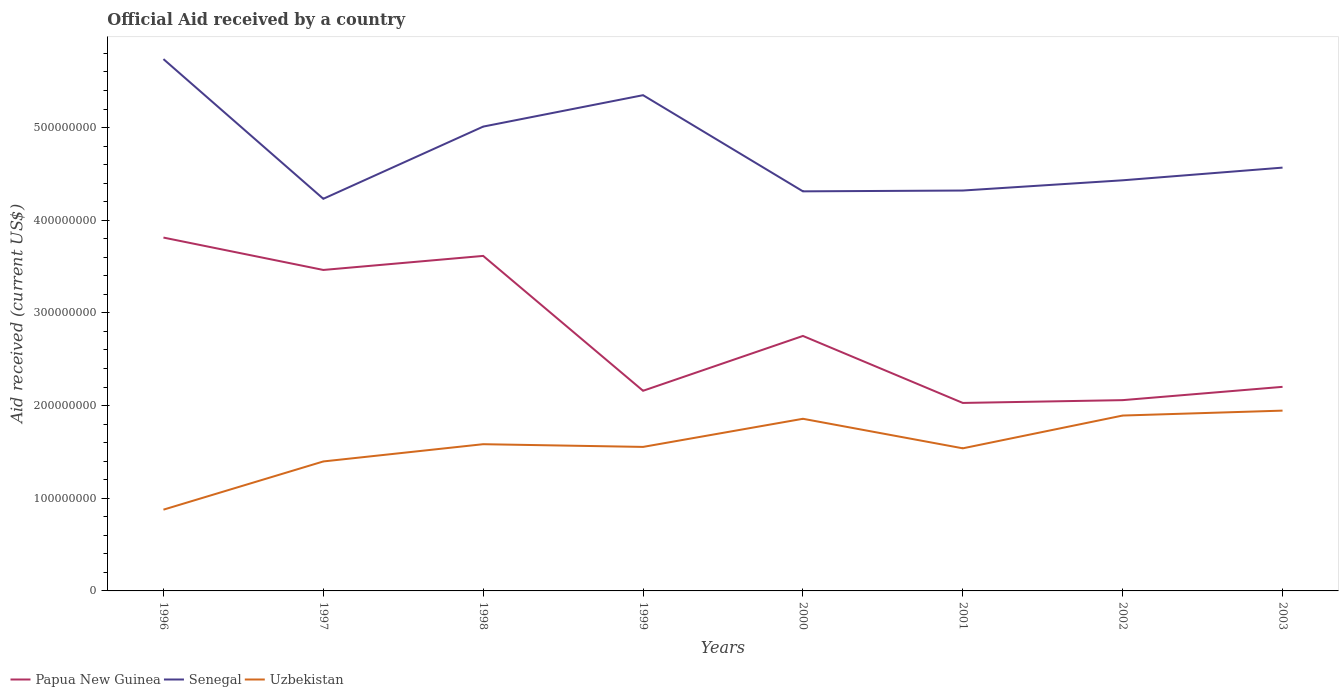Across all years, what is the maximum net official aid received in Papua New Guinea?
Your response must be concise. 2.03e+08. In which year was the net official aid received in Papua New Guinea maximum?
Your answer should be compact. 2001. What is the total net official aid received in Uzbekistan in the graph?
Your answer should be very brief. -3.09e+07. What is the difference between the highest and the second highest net official aid received in Papua New Guinea?
Provide a short and direct response. 1.78e+08. Is the net official aid received in Uzbekistan strictly greater than the net official aid received in Senegal over the years?
Offer a very short reply. Yes. Where does the legend appear in the graph?
Provide a succinct answer. Bottom left. What is the title of the graph?
Your answer should be very brief. Official Aid received by a country. Does "Bolivia" appear as one of the legend labels in the graph?
Provide a short and direct response. No. What is the label or title of the Y-axis?
Your answer should be compact. Aid received (current US$). What is the Aid received (current US$) of Papua New Guinea in 1996?
Your answer should be compact. 3.81e+08. What is the Aid received (current US$) in Senegal in 1996?
Ensure brevity in your answer.  5.74e+08. What is the Aid received (current US$) of Uzbekistan in 1996?
Make the answer very short. 8.77e+07. What is the Aid received (current US$) of Papua New Guinea in 1997?
Keep it short and to the point. 3.46e+08. What is the Aid received (current US$) in Senegal in 1997?
Keep it short and to the point. 4.23e+08. What is the Aid received (current US$) in Uzbekistan in 1997?
Ensure brevity in your answer.  1.40e+08. What is the Aid received (current US$) in Papua New Guinea in 1998?
Make the answer very short. 3.62e+08. What is the Aid received (current US$) in Senegal in 1998?
Your answer should be compact. 5.01e+08. What is the Aid received (current US$) in Uzbekistan in 1998?
Your answer should be compact. 1.58e+08. What is the Aid received (current US$) of Papua New Guinea in 1999?
Provide a short and direct response. 2.16e+08. What is the Aid received (current US$) of Senegal in 1999?
Your answer should be compact. 5.35e+08. What is the Aid received (current US$) of Uzbekistan in 1999?
Give a very brief answer. 1.55e+08. What is the Aid received (current US$) of Papua New Guinea in 2000?
Provide a short and direct response. 2.75e+08. What is the Aid received (current US$) in Senegal in 2000?
Provide a succinct answer. 4.31e+08. What is the Aid received (current US$) of Uzbekistan in 2000?
Provide a succinct answer. 1.86e+08. What is the Aid received (current US$) in Papua New Guinea in 2001?
Give a very brief answer. 2.03e+08. What is the Aid received (current US$) in Senegal in 2001?
Make the answer very short. 4.32e+08. What is the Aid received (current US$) of Uzbekistan in 2001?
Provide a short and direct response. 1.54e+08. What is the Aid received (current US$) in Papua New Guinea in 2002?
Offer a terse response. 2.06e+08. What is the Aid received (current US$) in Senegal in 2002?
Ensure brevity in your answer.  4.43e+08. What is the Aid received (current US$) in Uzbekistan in 2002?
Make the answer very short. 1.89e+08. What is the Aid received (current US$) of Papua New Guinea in 2003?
Give a very brief answer. 2.20e+08. What is the Aid received (current US$) of Senegal in 2003?
Offer a very short reply. 4.57e+08. What is the Aid received (current US$) of Uzbekistan in 2003?
Offer a very short reply. 1.95e+08. Across all years, what is the maximum Aid received (current US$) of Papua New Guinea?
Offer a terse response. 3.81e+08. Across all years, what is the maximum Aid received (current US$) of Senegal?
Your answer should be very brief. 5.74e+08. Across all years, what is the maximum Aid received (current US$) in Uzbekistan?
Offer a very short reply. 1.95e+08. Across all years, what is the minimum Aid received (current US$) in Papua New Guinea?
Make the answer very short. 2.03e+08. Across all years, what is the minimum Aid received (current US$) of Senegal?
Provide a succinct answer. 4.23e+08. Across all years, what is the minimum Aid received (current US$) in Uzbekistan?
Your answer should be very brief. 8.77e+07. What is the total Aid received (current US$) in Papua New Guinea in the graph?
Provide a short and direct response. 2.21e+09. What is the total Aid received (current US$) of Senegal in the graph?
Keep it short and to the point. 3.80e+09. What is the total Aid received (current US$) of Uzbekistan in the graph?
Provide a succinct answer. 1.26e+09. What is the difference between the Aid received (current US$) in Papua New Guinea in 1996 and that in 1997?
Offer a terse response. 3.50e+07. What is the difference between the Aid received (current US$) of Senegal in 1996 and that in 1997?
Provide a short and direct response. 1.51e+08. What is the difference between the Aid received (current US$) in Uzbekistan in 1996 and that in 1997?
Your answer should be very brief. -5.20e+07. What is the difference between the Aid received (current US$) of Papua New Guinea in 1996 and that in 1998?
Provide a succinct answer. 1.98e+07. What is the difference between the Aid received (current US$) in Senegal in 1996 and that in 1998?
Give a very brief answer. 7.28e+07. What is the difference between the Aid received (current US$) of Uzbekistan in 1996 and that in 1998?
Offer a very short reply. -7.06e+07. What is the difference between the Aid received (current US$) in Papua New Guinea in 1996 and that in 1999?
Your answer should be compact. 1.65e+08. What is the difference between the Aid received (current US$) of Senegal in 1996 and that in 1999?
Keep it short and to the point. 3.89e+07. What is the difference between the Aid received (current US$) in Uzbekistan in 1996 and that in 1999?
Your response must be concise. -6.77e+07. What is the difference between the Aid received (current US$) of Papua New Guinea in 1996 and that in 2000?
Your response must be concise. 1.06e+08. What is the difference between the Aid received (current US$) in Senegal in 1996 and that in 2000?
Give a very brief answer. 1.43e+08. What is the difference between the Aid received (current US$) of Uzbekistan in 1996 and that in 2000?
Make the answer very short. -9.81e+07. What is the difference between the Aid received (current US$) of Papua New Guinea in 1996 and that in 2001?
Offer a very short reply. 1.78e+08. What is the difference between the Aid received (current US$) of Senegal in 1996 and that in 2001?
Keep it short and to the point. 1.42e+08. What is the difference between the Aid received (current US$) of Uzbekistan in 1996 and that in 2001?
Ensure brevity in your answer.  -6.62e+07. What is the difference between the Aid received (current US$) of Papua New Guinea in 1996 and that in 2002?
Your answer should be very brief. 1.75e+08. What is the difference between the Aid received (current US$) of Senegal in 1996 and that in 2002?
Provide a succinct answer. 1.31e+08. What is the difference between the Aid received (current US$) in Uzbekistan in 1996 and that in 2002?
Ensure brevity in your answer.  -1.02e+08. What is the difference between the Aid received (current US$) of Papua New Guinea in 1996 and that in 2003?
Provide a short and direct response. 1.61e+08. What is the difference between the Aid received (current US$) in Senegal in 1996 and that in 2003?
Offer a terse response. 1.17e+08. What is the difference between the Aid received (current US$) in Uzbekistan in 1996 and that in 2003?
Make the answer very short. -1.07e+08. What is the difference between the Aid received (current US$) in Papua New Guinea in 1997 and that in 1998?
Provide a succinct answer. -1.52e+07. What is the difference between the Aid received (current US$) in Senegal in 1997 and that in 1998?
Your response must be concise. -7.79e+07. What is the difference between the Aid received (current US$) in Uzbekistan in 1997 and that in 1998?
Your answer should be compact. -1.86e+07. What is the difference between the Aid received (current US$) in Papua New Guinea in 1997 and that in 1999?
Your response must be concise. 1.30e+08. What is the difference between the Aid received (current US$) of Senegal in 1997 and that in 1999?
Your answer should be compact. -1.12e+08. What is the difference between the Aid received (current US$) of Uzbekistan in 1997 and that in 1999?
Provide a succinct answer. -1.57e+07. What is the difference between the Aid received (current US$) of Papua New Guinea in 1997 and that in 2000?
Offer a very short reply. 7.12e+07. What is the difference between the Aid received (current US$) of Senegal in 1997 and that in 2000?
Offer a terse response. -8.04e+06. What is the difference between the Aid received (current US$) in Uzbekistan in 1997 and that in 2000?
Your response must be concise. -4.60e+07. What is the difference between the Aid received (current US$) in Papua New Guinea in 1997 and that in 2001?
Make the answer very short. 1.44e+08. What is the difference between the Aid received (current US$) in Senegal in 1997 and that in 2001?
Your answer should be compact. -8.92e+06. What is the difference between the Aid received (current US$) of Uzbekistan in 1997 and that in 2001?
Make the answer very short. -1.42e+07. What is the difference between the Aid received (current US$) of Papua New Guinea in 1997 and that in 2002?
Ensure brevity in your answer.  1.40e+08. What is the difference between the Aid received (current US$) of Senegal in 1997 and that in 2002?
Offer a terse response. -2.00e+07. What is the difference between the Aid received (current US$) in Uzbekistan in 1997 and that in 2002?
Offer a very short reply. -4.95e+07. What is the difference between the Aid received (current US$) in Papua New Guinea in 1997 and that in 2003?
Offer a very short reply. 1.26e+08. What is the difference between the Aid received (current US$) of Senegal in 1997 and that in 2003?
Provide a short and direct response. -3.36e+07. What is the difference between the Aid received (current US$) of Uzbekistan in 1997 and that in 2003?
Give a very brief answer. -5.48e+07. What is the difference between the Aid received (current US$) of Papua New Guinea in 1998 and that in 1999?
Your answer should be compact. 1.46e+08. What is the difference between the Aid received (current US$) of Senegal in 1998 and that in 1999?
Give a very brief answer. -3.39e+07. What is the difference between the Aid received (current US$) in Uzbekistan in 1998 and that in 1999?
Offer a very short reply. 2.93e+06. What is the difference between the Aid received (current US$) in Papua New Guinea in 1998 and that in 2000?
Offer a terse response. 8.64e+07. What is the difference between the Aid received (current US$) of Senegal in 1998 and that in 2000?
Your answer should be very brief. 6.99e+07. What is the difference between the Aid received (current US$) in Uzbekistan in 1998 and that in 2000?
Keep it short and to the point. -2.74e+07. What is the difference between the Aid received (current US$) in Papua New Guinea in 1998 and that in 2001?
Provide a short and direct response. 1.59e+08. What is the difference between the Aid received (current US$) of Senegal in 1998 and that in 2001?
Keep it short and to the point. 6.90e+07. What is the difference between the Aid received (current US$) of Uzbekistan in 1998 and that in 2001?
Provide a short and direct response. 4.45e+06. What is the difference between the Aid received (current US$) of Papua New Guinea in 1998 and that in 2002?
Provide a succinct answer. 1.56e+08. What is the difference between the Aid received (current US$) in Senegal in 1998 and that in 2002?
Your answer should be compact. 5.80e+07. What is the difference between the Aid received (current US$) of Uzbekistan in 1998 and that in 2002?
Your answer should be very brief. -3.09e+07. What is the difference between the Aid received (current US$) of Papua New Guinea in 1998 and that in 2003?
Offer a terse response. 1.41e+08. What is the difference between the Aid received (current US$) of Senegal in 1998 and that in 2003?
Your answer should be compact. 4.43e+07. What is the difference between the Aid received (current US$) in Uzbekistan in 1998 and that in 2003?
Provide a short and direct response. -3.62e+07. What is the difference between the Aid received (current US$) in Papua New Guinea in 1999 and that in 2000?
Your answer should be compact. -5.92e+07. What is the difference between the Aid received (current US$) of Senegal in 1999 and that in 2000?
Provide a short and direct response. 1.04e+08. What is the difference between the Aid received (current US$) in Uzbekistan in 1999 and that in 2000?
Offer a very short reply. -3.04e+07. What is the difference between the Aid received (current US$) of Papua New Guinea in 1999 and that in 2001?
Your answer should be very brief. 1.31e+07. What is the difference between the Aid received (current US$) in Senegal in 1999 and that in 2001?
Your answer should be very brief. 1.03e+08. What is the difference between the Aid received (current US$) in Uzbekistan in 1999 and that in 2001?
Make the answer very short. 1.52e+06. What is the difference between the Aid received (current US$) of Papua New Guinea in 1999 and that in 2002?
Your response must be concise. 1.01e+07. What is the difference between the Aid received (current US$) of Senegal in 1999 and that in 2002?
Provide a short and direct response. 9.18e+07. What is the difference between the Aid received (current US$) of Uzbekistan in 1999 and that in 2002?
Offer a terse response. -3.38e+07. What is the difference between the Aid received (current US$) of Papua New Guinea in 1999 and that in 2003?
Your answer should be compact. -4.25e+06. What is the difference between the Aid received (current US$) in Senegal in 1999 and that in 2003?
Provide a short and direct response. 7.82e+07. What is the difference between the Aid received (current US$) of Uzbekistan in 1999 and that in 2003?
Make the answer very short. -3.92e+07. What is the difference between the Aid received (current US$) of Papua New Guinea in 2000 and that in 2001?
Offer a very short reply. 7.23e+07. What is the difference between the Aid received (current US$) in Senegal in 2000 and that in 2001?
Provide a succinct answer. -8.80e+05. What is the difference between the Aid received (current US$) of Uzbekistan in 2000 and that in 2001?
Ensure brevity in your answer.  3.19e+07. What is the difference between the Aid received (current US$) in Papua New Guinea in 2000 and that in 2002?
Your answer should be compact. 6.93e+07. What is the difference between the Aid received (current US$) of Senegal in 2000 and that in 2002?
Keep it short and to the point. -1.19e+07. What is the difference between the Aid received (current US$) of Uzbekistan in 2000 and that in 2002?
Provide a succinct answer. -3.50e+06. What is the difference between the Aid received (current US$) of Papua New Guinea in 2000 and that in 2003?
Make the answer very short. 5.49e+07. What is the difference between the Aid received (current US$) in Senegal in 2000 and that in 2003?
Your response must be concise. -2.56e+07. What is the difference between the Aid received (current US$) of Uzbekistan in 2000 and that in 2003?
Give a very brief answer. -8.80e+06. What is the difference between the Aid received (current US$) of Papua New Guinea in 2001 and that in 2002?
Your answer should be compact. -3.02e+06. What is the difference between the Aid received (current US$) in Senegal in 2001 and that in 2002?
Give a very brief answer. -1.10e+07. What is the difference between the Aid received (current US$) in Uzbekistan in 2001 and that in 2002?
Offer a very short reply. -3.54e+07. What is the difference between the Aid received (current US$) of Papua New Guinea in 2001 and that in 2003?
Your answer should be very brief. -1.74e+07. What is the difference between the Aid received (current US$) in Senegal in 2001 and that in 2003?
Give a very brief answer. -2.47e+07. What is the difference between the Aid received (current US$) of Uzbekistan in 2001 and that in 2003?
Provide a short and direct response. -4.07e+07. What is the difference between the Aid received (current US$) in Papua New Guinea in 2002 and that in 2003?
Your answer should be very brief. -1.44e+07. What is the difference between the Aid received (current US$) of Senegal in 2002 and that in 2003?
Your response must be concise. -1.37e+07. What is the difference between the Aid received (current US$) of Uzbekistan in 2002 and that in 2003?
Your answer should be very brief. -5.30e+06. What is the difference between the Aid received (current US$) in Papua New Guinea in 1996 and the Aid received (current US$) in Senegal in 1997?
Your response must be concise. -4.18e+07. What is the difference between the Aid received (current US$) in Papua New Guinea in 1996 and the Aid received (current US$) in Uzbekistan in 1997?
Provide a succinct answer. 2.42e+08. What is the difference between the Aid received (current US$) of Senegal in 1996 and the Aid received (current US$) of Uzbekistan in 1997?
Offer a terse response. 4.34e+08. What is the difference between the Aid received (current US$) in Papua New Guinea in 1996 and the Aid received (current US$) in Senegal in 1998?
Keep it short and to the point. -1.20e+08. What is the difference between the Aid received (current US$) of Papua New Guinea in 1996 and the Aid received (current US$) of Uzbekistan in 1998?
Your answer should be compact. 2.23e+08. What is the difference between the Aid received (current US$) of Senegal in 1996 and the Aid received (current US$) of Uzbekistan in 1998?
Give a very brief answer. 4.16e+08. What is the difference between the Aid received (current US$) in Papua New Guinea in 1996 and the Aid received (current US$) in Senegal in 1999?
Provide a succinct answer. -1.54e+08. What is the difference between the Aid received (current US$) in Papua New Guinea in 1996 and the Aid received (current US$) in Uzbekistan in 1999?
Give a very brief answer. 2.26e+08. What is the difference between the Aid received (current US$) of Senegal in 1996 and the Aid received (current US$) of Uzbekistan in 1999?
Your answer should be compact. 4.18e+08. What is the difference between the Aid received (current US$) in Papua New Guinea in 1996 and the Aid received (current US$) in Senegal in 2000?
Provide a short and direct response. -4.99e+07. What is the difference between the Aid received (current US$) in Papua New Guinea in 1996 and the Aid received (current US$) in Uzbekistan in 2000?
Make the answer very short. 1.96e+08. What is the difference between the Aid received (current US$) in Senegal in 1996 and the Aid received (current US$) in Uzbekistan in 2000?
Ensure brevity in your answer.  3.88e+08. What is the difference between the Aid received (current US$) in Papua New Guinea in 1996 and the Aid received (current US$) in Senegal in 2001?
Offer a very short reply. -5.08e+07. What is the difference between the Aid received (current US$) of Papua New Guinea in 1996 and the Aid received (current US$) of Uzbekistan in 2001?
Provide a short and direct response. 2.27e+08. What is the difference between the Aid received (current US$) of Senegal in 1996 and the Aid received (current US$) of Uzbekistan in 2001?
Ensure brevity in your answer.  4.20e+08. What is the difference between the Aid received (current US$) of Papua New Guinea in 1996 and the Aid received (current US$) of Senegal in 2002?
Your answer should be compact. -6.18e+07. What is the difference between the Aid received (current US$) in Papua New Guinea in 1996 and the Aid received (current US$) in Uzbekistan in 2002?
Offer a very short reply. 1.92e+08. What is the difference between the Aid received (current US$) of Senegal in 1996 and the Aid received (current US$) of Uzbekistan in 2002?
Give a very brief answer. 3.85e+08. What is the difference between the Aid received (current US$) in Papua New Guinea in 1996 and the Aid received (current US$) in Senegal in 2003?
Give a very brief answer. -7.55e+07. What is the difference between the Aid received (current US$) of Papua New Guinea in 1996 and the Aid received (current US$) of Uzbekistan in 2003?
Give a very brief answer. 1.87e+08. What is the difference between the Aid received (current US$) of Senegal in 1996 and the Aid received (current US$) of Uzbekistan in 2003?
Your answer should be very brief. 3.79e+08. What is the difference between the Aid received (current US$) in Papua New Guinea in 1997 and the Aid received (current US$) in Senegal in 1998?
Your answer should be compact. -1.55e+08. What is the difference between the Aid received (current US$) in Papua New Guinea in 1997 and the Aid received (current US$) in Uzbekistan in 1998?
Make the answer very short. 1.88e+08. What is the difference between the Aid received (current US$) in Senegal in 1997 and the Aid received (current US$) in Uzbekistan in 1998?
Keep it short and to the point. 2.65e+08. What is the difference between the Aid received (current US$) in Papua New Guinea in 1997 and the Aid received (current US$) in Senegal in 1999?
Provide a short and direct response. -1.89e+08. What is the difference between the Aid received (current US$) in Papua New Guinea in 1997 and the Aid received (current US$) in Uzbekistan in 1999?
Keep it short and to the point. 1.91e+08. What is the difference between the Aid received (current US$) of Senegal in 1997 and the Aid received (current US$) of Uzbekistan in 1999?
Make the answer very short. 2.68e+08. What is the difference between the Aid received (current US$) in Papua New Guinea in 1997 and the Aid received (current US$) in Senegal in 2000?
Make the answer very short. -8.48e+07. What is the difference between the Aid received (current US$) in Papua New Guinea in 1997 and the Aid received (current US$) in Uzbekistan in 2000?
Offer a terse response. 1.61e+08. What is the difference between the Aid received (current US$) of Senegal in 1997 and the Aid received (current US$) of Uzbekistan in 2000?
Your answer should be compact. 2.37e+08. What is the difference between the Aid received (current US$) of Papua New Guinea in 1997 and the Aid received (current US$) of Senegal in 2001?
Offer a terse response. -8.57e+07. What is the difference between the Aid received (current US$) in Papua New Guinea in 1997 and the Aid received (current US$) in Uzbekistan in 2001?
Give a very brief answer. 1.92e+08. What is the difference between the Aid received (current US$) in Senegal in 1997 and the Aid received (current US$) in Uzbekistan in 2001?
Keep it short and to the point. 2.69e+08. What is the difference between the Aid received (current US$) in Papua New Guinea in 1997 and the Aid received (current US$) in Senegal in 2002?
Make the answer very short. -9.68e+07. What is the difference between the Aid received (current US$) in Papua New Guinea in 1997 and the Aid received (current US$) in Uzbekistan in 2002?
Offer a very short reply. 1.57e+08. What is the difference between the Aid received (current US$) of Senegal in 1997 and the Aid received (current US$) of Uzbekistan in 2002?
Provide a succinct answer. 2.34e+08. What is the difference between the Aid received (current US$) in Papua New Guinea in 1997 and the Aid received (current US$) in Senegal in 2003?
Provide a short and direct response. -1.10e+08. What is the difference between the Aid received (current US$) of Papua New Guinea in 1997 and the Aid received (current US$) of Uzbekistan in 2003?
Offer a very short reply. 1.52e+08. What is the difference between the Aid received (current US$) in Senegal in 1997 and the Aid received (current US$) in Uzbekistan in 2003?
Your answer should be compact. 2.29e+08. What is the difference between the Aid received (current US$) in Papua New Guinea in 1998 and the Aid received (current US$) in Senegal in 1999?
Give a very brief answer. -1.73e+08. What is the difference between the Aid received (current US$) of Papua New Guinea in 1998 and the Aid received (current US$) of Uzbekistan in 1999?
Your answer should be very brief. 2.06e+08. What is the difference between the Aid received (current US$) in Senegal in 1998 and the Aid received (current US$) in Uzbekistan in 1999?
Keep it short and to the point. 3.46e+08. What is the difference between the Aid received (current US$) of Papua New Guinea in 1998 and the Aid received (current US$) of Senegal in 2000?
Offer a terse response. -6.97e+07. What is the difference between the Aid received (current US$) of Papua New Guinea in 1998 and the Aid received (current US$) of Uzbekistan in 2000?
Give a very brief answer. 1.76e+08. What is the difference between the Aid received (current US$) of Senegal in 1998 and the Aid received (current US$) of Uzbekistan in 2000?
Your answer should be compact. 3.15e+08. What is the difference between the Aid received (current US$) in Papua New Guinea in 1998 and the Aid received (current US$) in Senegal in 2001?
Provide a short and direct response. -7.06e+07. What is the difference between the Aid received (current US$) in Papua New Guinea in 1998 and the Aid received (current US$) in Uzbekistan in 2001?
Offer a terse response. 2.08e+08. What is the difference between the Aid received (current US$) of Senegal in 1998 and the Aid received (current US$) of Uzbekistan in 2001?
Ensure brevity in your answer.  3.47e+08. What is the difference between the Aid received (current US$) in Papua New Guinea in 1998 and the Aid received (current US$) in Senegal in 2002?
Ensure brevity in your answer.  -8.16e+07. What is the difference between the Aid received (current US$) in Papua New Guinea in 1998 and the Aid received (current US$) in Uzbekistan in 2002?
Give a very brief answer. 1.72e+08. What is the difference between the Aid received (current US$) in Senegal in 1998 and the Aid received (current US$) in Uzbekistan in 2002?
Keep it short and to the point. 3.12e+08. What is the difference between the Aid received (current US$) of Papua New Guinea in 1998 and the Aid received (current US$) of Senegal in 2003?
Offer a terse response. -9.53e+07. What is the difference between the Aid received (current US$) of Papua New Guinea in 1998 and the Aid received (current US$) of Uzbekistan in 2003?
Keep it short and to the point. 1.67e+08. What is the difference between the Aid received (current US$) of Senegal in 1998 and the Aid received (current US$) of Uzbekistan in 2003?
Offer a terse response. 3.06e+08. What is the difference between the Aid received (current US$) of Papua New Guinea in 1999 and the Aid received (current US$) of Senegal in 2000?
Keep it short and to the point. -2.15e+08. What is the difference between the Aid received (current US$) in Papua New Guinea in 1999 and the Aid received (current US$) in Uzbekistan in 2000?
Provide a succinct answer. 3.02e+07. What is the difference between the Aid received (current US$) of Senegal in 1999 and the Aid received (current US$) of Uzbekistan in 2000?
Offer a terse response. 3.49e+08. What is the difference between the Aid received (current US$) of Papua New Guinea in 1999 and the Aid received (current US$) of Senegal in 2001?
Offer a very short reply. -2.16e+08. What is the difference between the Aid received (current US$) in Papua New Guinea in 1999 and the Aid received (current US$) in Uzbekistan in 2001?
Your response must be concise. 6.21e+07. What is the difference between the Aid received (current US$) of Senegal in 1999 and the Aid received (current US$) of Uzbekistan in 2001?
Provide a succinct answer. 3.81e+08. What is the difference between the Aid received (current US$) in Papua New Guinea in 1999 and the Aid received (current US$) in Senegal in 2002?
Your answer should be compact. -2.27e+08. What is the difference between the Aid received (current US$) of Papua New Guinea in 1999 and the Aid received (current US$) of Uzbekistan in 2002?
Provide a short and direct response. 2.67e+07. What is the difference between the Aid received (current US$) in Senegal in 1999 and the Aid received (current US$) in Uzbekistan in 2002?
Provide a short and direct response. 3.46e+08. What is the difference between the Aid received (current US$) in Papua New Guinea in 1999 and the Aid received (current US$) in Senegal in 2003?
Offer a terse response. -2.41e+08. What is the difference between the Aid received (current US$) of Papua New Guinea in 1999 and the Aid received (current US$) of Uzbekistan in 2003?
Provide a succinct answer. 2.14e+07. What is the difference between the Aid received (current US$) in Senegal in 1999 and the Aid received (current US$) in Uzbekistan in 2003?
Your response must be concise. 3.40e+08. What is the difference between the Aid received (current US$) in Papua New Guinea in 2000 and the Aid received (current US$) in Senegal in 2001?
Provide a short and direct response. -1.57e+08. What is the difference between the Aid received (current US$) in Papua New Guinea in 2000 and the Aid received (current US$) in Uzbekistan in 2001?
Give a very brief answer. 1.21e+08. What is the difference between the Aid received (current US$) of Senegal in 2000 and the Aid received (current US$) of Uzbekistan in 2001?
Offer a very short reply. 2.77e+08. What is the difference between the Aid received (current US$) in Papua New Guinea in 2000 and the Aid received (current US$) in Senegal in 2002?
Offer a very short reply. -1.68e+08. What is the difference between the Aid received (current US$) of Papua New Guinea in 2000 and the Aid received (current US$) of Uzbekistan in 2002?
Your response must be concise. 8.59e+07. What is the difference between the Aid received (current US$) in Senegal in 2000 and the Aid received (current US$) in Uzbekistan in 2002?
Ensure brevity in your answer.  2.42e+08. What is the difference between the Aid received (current US$) in Papua New Guinea in 2000 and the Aid received (current US$) in Senegal in 2003?
Ensure brevity in your answer.  -1.82e+08. What is the difference between the Aid received (current US$) in Papua New Guinea in 2000 and the Aid received (current US$) in Uzbekistan in 2003?
Offer a terse response. 8.06e+07. What is the difference between the Aid received (current US$) of Senegal in 2000 and the Aid received (current US$) of Uzbekistan in 2003?
Provide a succinct answer. 2.37e+08. What is the difference between the Aid received (current US$) of Papua New Guinea in 2001 and the Aid received (current US$) of Senegal in 2002?
Offer a very short reply. -2.40e+08. What is the difference between the Aid received (current US$) in Papua New Guinea in 2001 and the Aid received (current US$) in Uzbekistan in 2002?
Provide a short and direct response. 1.36e+07. What is the difference between the Aid received (current US$) in Senegal in 2001 and the Aid received (current US$) in Uzbekistan in 2002?
Provide a short and direct response. 2.43e+08. What is the difference between the Aid received (current US$) in Papua New Guinea in 2001 and the Aid received (current US$) in Senegal in 2003?
Offer a very short reply. -2.54e+08. What is the difference between the Aid received (current US$) of Papua New Guinea in 2001 and the Aid received (current US$) of Uzbekistan in 2003?
Your answer should be very brief. 8.30e+06. What is the difference between the Aid received (current US$) of Senegal in 2001 and the Aid received (current US$) of Uzbekistan in 2003?
Offer a very short reply. 2.38e+08. What is the difference between the Aid received (current US$) in Papua New Guinea in 2002 and the Aid received (current US$) in Senegal in 2003?
Give a very brief answer. -2.51e+08. What is the difference between the Aid received (current US$) of Papua New Guinea in 2002 and the Aid received (current US$) of Uzbekistan in 2003?
Keep it short and to the point. 1.13e+07. What is the difference between the Aid received (current US$) in Senegal in 2002 and the Aid received (current US$) in Uzbekistan in 2003?
Make the answer very short. 2.49e+08. What is the average Aid received (current US$) of Papua New Guinea per year?
Give a very brief answer. 2.76e+08. What is the average Aid received (current US$) in Senegal per year?
Offer a terse response. 4.75e+08. What is the average Aid received (current US$) of Uzbekistan per year?
Provide a succinct answer. 1.58e+08. In the year 1996, what is the difference between the Aid received (current US$) of Papua New Guinea and Aid received (current US$) of Senegal?
Offer a very short reply. -1.93e+08. In the year 1996, what is the difference between the Aid received (current US$) in Papua New Guinea and Aid received (current US$) in Uzbekistan?
Your answer should be compact. 2.94e+08. In the year 1996, what is the difference between the Aid received (current US$) in Senegal and Aid received (current US$) in Uzbekistan?
Provide a succinct answer. 4.86e+08. In the year 1997, what is the difference between the Aid received (current US$) of Papua New Guinea and Aid received (current US$) of Senegal?
Keep it short and to the point. -7.68e+07. In the year 1997, what is the difference between the Aid received (current US$) in Papua New Guinea and Aid received (current US$) in Uzbekistan?
Give a very brief answer. 2.07e+08. In the year 1997, what is the difference between the Aid received (current US$) in Senegal and Aid received (current US$) in Uzbekistan?
Ensure brevity in your answer.  2.83e+08. In the year 1998, what is the difference between the Aid received (current US$) of Papua New Guinea and Aid received (current US$) of Senegal?
Provide a short and direct response. -1.40e+08. In the year 1998, what is the difference between the Aid received (current US$) of Papua New Guinea and Aid received (current US$) of Uzbekistan?
Your answer should be compact. 2.03e+08. In the year 1998, what is the difference between the Aid received (current US$) of Senegal and Aid received (current US$) of Uzbekistan?
Provide a short and direct response. 3.43e+08. In the year 1999, what is the difference between the Aid received (current US$) in Papua New Guinea and Aid received (current US$) in Senegal?
Give a very brief answer. -3.19e+08. In the year 1999, what is the difference between the Aid received (current US$) in Papua New Guinea and Aid received (current US$) in Uzbekistan?
Offer a very short reply. 6.06e+07. In the year 1999, what is the difference between the Aid received (current US$) of Senegal and Aid received (current US$) of Uzbekistan?
Your answer should be very brief. 3.80e+08. In the year 2000, what is the difference between the Aid received (current US$) of Papua New Guinea and Aid received (current US$) of Senegal?
Your answer should be compact. -1.56e+08. In the year 2000, what is the difference between the Aid received (current US$) of Papua New Guinea and Aid received (current US$) of Uzbekistan?
Give a very brief answer. 8.94e+07. In the year 2000, what is the difference between the Aid received (current US$) in Senegal and Aid received (current US$) in Uzbekistan?
Your response must be concise. 2.45e+08. In the year 2001, what is the difference between the Aid received (current US$) in Papua New Guinea and Aid received (current US$) in Senegal?
Offer a terse response. -2.29e+08. In the year 2001, what is the difference between the Aid received (current US$) in Papua New Guinea and Aid received (current US$) in Uzbekistan?
Your response must be concise. 4.90e+07. In the year 2001, what is the difference between the Aid received (current US$) of Senegal and Aid received (current US$) of Uzbekistan?
Give a very brief answer. 2.78e+08. In the year 2002, what is the difference between the Aid received (current US$) in Papua New Guinea and Aid received (current US$) in Senegal?
Your answer should be compact. -2.37e+08. In the year 2002, what is the difference between the Aid received (current US$) in Papua New Guinea and Aid received (current US$) in Uzbekistan?
Your answer should be compact. 1.66e+07. In the year 2002, what is the difference between the Aid received (current US$) of Senegal and Aid received (current US$) of Uzbekistan?
Provide a short and direct response. 2.54e+08. In the year 2003, what is the difference between the Aid received (current US$) in Papua New Guinea and Aid received (current US$) in Senegal?
Keep it short and to the point. -2.37e+08. In the year 2003, what is the difference between the Aid received (current US$) of Papua New Guinea and Aid received (current US$) of Uzbekistan?
Provide a succinct answer. 2.57e+07. In the year 2003, what is the difference between the Aid received (current US$) in Senegal and Aid received (current US$) in Uzbekistan?
Your answer should be very brief. 2.62e+08. What is the ratio of the Aid received (current US$) in Papua New Guinea in 1996 to that in 1997?
Make the answer very short. 1.1. What is the ratio of the Aid received (current US$) of Senegal in 1996 to that in 1997?
Keep it short and to the point. 1.36. What is the ratio of the Aid received (current US$) in Uzbekistan in 1996 to that in 1997?
Offer a terse response. 0.63. What is the ratio of the Aid received (current US$) of Papua New Guinea in 1996 to that in 1998?
Provide a short and direct response. 1.05. What is the ratio of the Aid received (current US$) in Senegal in 1996 to that in 1998?
Provide a short and direct response. 1.15. What is the ratio of the Aid received (current US$) of Uzbekistan in 1996 to that in 1998?
Provide a short and direct response. 0.55. What is the ratio of the Aid received (current US$) in Papua New Guinea in 1996 to that in 1999?
Provide a succinct answer. 1.77. What is the ratio of the Aid received (current US$) of Senegal in 1996 to that in 1999?
Provide a succinct answer. 1.07. What is the ratio of the Aid received (current US$) in Uzbekistan in 1996 to that in 1999?
Make the answer very short. 0.56. What is the ratio of the Aid received (current US$) in Papua New Guinea in 1996 to that in 2000?
Offer a terse response. 1.39. What is the ratio of the Aid received (current US$) in Senegal in 1996 to that in 2000?
Provide a succinct answer. 1.33. What is the ratio of the Aid received (current US$) in Uzbekistan in 1996 to that in 2000?
Ensure brevity in your answer.  0.47. What is the ratio of the Aid received (current US$) of Papua New Guinea in 1996 to that in 2001?
Offer a terse response. 1.88. What is the ratio of the Aid received (current US$) of Senegal in 1996 to that in 2001?
Your answer should be very brief. 1.33. What is the ratio of the Aid received (current US$) in Uzbekistan in 1996 to that in 2001?
Provide a short and direct response. 0.57. What is the ratio of the Aid received (current US$) of Papua New Guinea in 1996 to that in 2002?
Your response must be concise. 1.85. What is the ratio of the Aid received (current US$) of Senegal in 1996 to that in 2002?
Give a very brief answer. 1.3. What is the ratio of the Aid received (current US$) in Uzbekistan in 1996 to that in 2002?
Your answer should be compact. 0.46. What is the ratio of the Aid received (current US$) of Papua New Guinea in 1996 to that in 2003?
Your response must be concise. 1.73. What is the ratio of the Aid received (current US$) of Senegal in 1996 to that in 2003?
Offer a terse response. 1.26. What is the ratio of the Aid received (current US$) of Uzbekistan in 1996 to that in 2003?
Make the answer very short. 0.45. What is the ratio of the Aid received (current US$) in Papua New Guinea in 1997 to that in 1998?
Make the answer very short. 0.96. What is the ratio of the Aid received (current US$) in Senegal in 1997 to that in 1998?
Offer a terse response. 0.84. What is the ratio of the Aid received (current US$) in Uzbekistan in 1997 to that in 1998?
Your answer should be very brief. 0.88. What is the ratio of the Aid received (current US$) of Papua New Guinea in 1997 to that in 1999?
Your response must be concise. 1.6. What is the ratio of the Aid received (current US$) in Senegal in 1997 to that in 1999?
Give a very brief answer. 0.79. What is the ratio of the Aid received (current US$) in Uzbekistan in 1997 to that in 1999?
Ensure brevity in your answer.  0.9. What is the ratio of the Aid received (current US$) of Papua New Guinea in 1997 to that in 2000?
Provide a short and direct response. 1.26. What is the ratio of the Aid received (current US$) in Senegal in 1997 to that in 2000?
Your answer should be compact. 0.98. What is the ratio of the Aid received (current US$) in Uzbekistan in 1997 to that in 2000?
Keep it short and to the point. 0.75. What is the ratio of the Aid received (current US$) in Papua New Guinea in 1997 to that in 2001?
Ensure brevity in your answer.  1.71. What is the ratio of the Aid received (current US$) of Senegal in 1997 to that in 2001?
Provide a succinct answer. 0.98. What is the ratio of the Aid received (current US$) of Uzbekistan in 1997 to that in 2001?
Ensure brevity in your answer.  0.91. What is the ratio of the Aid received (current US$) in Papua New Guinea in 1997 to that in 2002?
Make the answer very short. 1.68. What is the ratio of the Aid received (current US$) in Senegal in 1997 to that in 2002?
Offer a terse response. 0.95. What is the ratio of the Aid received (current US$) in Uzbekistan in 1997 to that in 2002?
Ensure brevity in your answer.  0.74. What is the ratio of the Aid received (current US$) of Papua New Guinea in 1997 to that in 2003?
Offer a terse response. 1.57. What is the ratio of the Aid received (current US$) of Senegal in 1997 to that in 2003?
Offer a very short reply. 0.93. What is the ratio of the Aid received (current US$) of Uzbekistan in 1997 to that in 2003?
Make the answer very short. 0.72. What is the ratio of the Aid received (current US$) of Papua New Guinea in 1998 to that in 1999?
Ensure brevity in your answer.  1.67. What is the ratio of the Aid received (current US$) of Senegal in 1998 to that in 1999?
Make the answer very short. 0.94. What is the ratio of the Aid received (current US$) in Uzbekistan in 1998 to that in 1999?
Your answer should be compact. 1.02. What is the ratio of the Aid received (current US$) of Papua New Guinea in 1998 to that in 2000?
Make the answer very short. 1.31. What is the ratio of the Aid received (current US$) in Senegal in 1998 to that in 2000?
Provide a succinct answer. 1.16. What is the ratio of the Aid received (current US$) of Uzbekistan in 1998 to that in 2000?
Your answer should be compact. 0.85. What is the ratio of the Aid received (current US$) of Papua New Guinea in 1998 to that in 2001?
Give a very brief answer. 1.78. What is the ratio of the Aid received (current US$) in Senegal in 1998 to that in 2001?
Provide a short and direct response. 1.16. What is the ratio of the Aid received (current US$) of Uzbekistan in 1998 to that in 2001?
Provide a succinct answer. 1.03. What is the ratio of the Aid received (current US$) of Papua New Guinea in 1998 to that in 2002?
Offer a very short reply. 1.76. What is the ratio of the Aid received (current US$) in Senegal in 1998 to that in 2002?
Provide a succinct answer. 1.13. What is the ratio of the Aid received (current US$) in Uzbekistan in 1998 to that in 2002?
Keep it short and to the point. 0.84. What is the ratio of the Aid received (current US$) of Papua New Guinea in 1998 to that in 2003?
Keep it short and to the point. 1.64. What is the ratio of the Aid received (current US$) of Senegal in 1998 to that in 2003?
Your answer should be compact. 1.1. What is the ratio of the Aid received (current US$) of Uzbekistan in 1998 to that in 2003?
Keep it short and to the point. 0.81. What is the ratio of the Aid received (current US$) in Papua New Guinea in 1999 to that in 2000?
Offer a terse response. 0.78. What is the ratio of the Aid received (current US$) of Senegal in 1999 to that in 2000?
Provide a short and direct response. 1.24. What is the ratio of the Aid received (current US$) in Uzbekistan in 1999 to that in 2000?
Offer a very short reply. 0.84. What is the ratio of the Aid received (current US$) in Papua New Guinea in 1999 to that in 2001?
Offer a terse response. 1.06. What is the ratio of the Aid received (current US$) of Senegal in 1999 to that in 2001?
Provide a short and direct response. 1.24. What is the ratio of the Aid received (current US$) of Uzbekistan in 1999 to that in 2001?
Give a very brief answer. 1.01. What is the ratio of the Aid received (current US$) of Papua New Guinea in 1999 to that in 2002?
Give a very brief answer. 1.05. What is the ratio of the Aid received (current US$) of Senegal in 1999 to that in 2002?
Offer a very short reply. 1.21. What is the ratio of the Aid received (current US$) of Uzbekistan in 1999 to that in 2002?
Your response must be concise. 0.82. What is the ratio of the Aid received (current US$) in Papua New Guinea in 1999 to that in 2003?
Your response must be concise. 0.98. What is the ratio of the Aid received (current US$) of Senegal in 1999 to that in 2003?
Give a very brief answer. 1.17. What is the ratio of the Aid received (current US$) of Uzbekistan in 1999 to that in 2003?
Offer a very short reply. 0.8. What is the ratio of the Aid received (current US$) of Papua New Guinea in 2000 to that in 2001?
Provide a short and direct response. 1.36. What is the ratio of the Aid received (current US$) of Senegal in 2000 to that in 2001?
Offer a terse response. 1. What is the ratio of the Aid received (current US$) of Uzbekistan in 2000 to that in 2001?
Provide a succinct answer. 1.21. What is the ratio of the Aid received (current US$) of Papua New Guinea in 2000 to that in 2002?
Give a very brief answer. 1.34. What is the ratio of the Aid received (current US$) of Senegal in 2000 to that in 2002?
Your response must be concise. 0.97. What is the ratio of the Aid received (current US$) in Uzbekistan in 2000 to that in 2002?
Ensure brevity in your answer.  0.98. What is the ratio of the Aid received (current US$) in Papua New Guinea in 2000 to that in 2003?
Provide a succinct answer. 1.25. What is the ratio of the Aid received (current US$) of Senegal in 2000 to that in 2003?
Make the answer very short. 0.94. What is the ratio of the Aid received (current US$) in Uzbekistan in 2000 to that in 2003?
Ensure brevity in your answer.  0.95. What is the ratio of the Aid received (current US$) of Senegal in 2001 to that in 2002?
Provide a short and direct response. 0.98. What is the ratio of the Aid received (current US$) of Uzbekistan in 2001 to that in 2002?
Your response must be concise. 0.81. What is the ratio of the Aid received (current US$) in Papua New Guinea in 2001 to that in 2003?
Your response must be concise. 0.92. What is the ratio of the Aid received (current US$) of Senegal in 2001 to that in 2003?
Ensure brevity in your answer.  0.95. What is the ratio of the Aid received (current US$) in Uzbekistan in 2001 to that in 2003?
Ensure brevity in your answer.  0.79. What is the ratio of the Aid received (current US$) in Papua New Guinea in 2002 to that in 2003?
Provide a short and direct response. 0.93. What is the ratio of the Aid received (current US$) in Senegal in 2002 to that in 2003?
Provide a succinct answer. 0.97. What is the ratio of the Aid received (current US$) in Uzbekistan in 2002 to that in 2003?
Provide a succinct answer. 0.97. What is the difference between the highest and the second highest Aid received (current US$) of Papua New Guinea?
Ensure brevity in your answer.  1.98e+07. What is the difference between the highest and the second highest Aid received (current US$) in Senegal?
Provide a short and direct response. 3.89e+07. What is the difference between the highest and the second highest Aid received (current US$) in Uzbekistan?
Offer a terse response. 5.30e+06. What is the difference between the highest and the lowest Aid received (current US$) of Papua New Guinea?
Ensure brevity in your answer.  1.78e+08. What is the difference between the highest and the lowest Aid received (current US$) of Senegal?
Your answer should be compact. 1.51e+08. What is the difference between the highest and the lowest Aid received (current US$) of Uzbekistan?
Your response must be concise. 1.07e+08. 